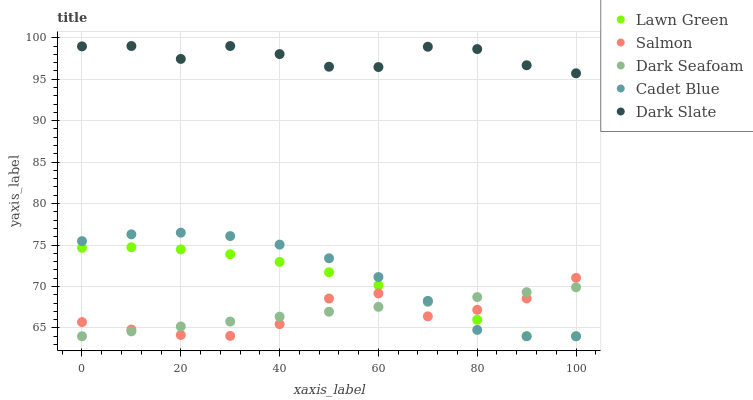Does Salmon have the minimum area under the curve?
Answer yes or no. Yes. Does Dark Slate have the maximum area under the curve?
Answer yes or no. Yes. Does Dark Seafoam have the minimum area under the curve?
Answer yes or no. No. Does Dark Seafoam have the maximum area under the curve?
Answer yes or no. No. Is Dark Seafoam the smoothest?
Answer yes or no. Yes. Is Dark Slate the roughest?
Answer yes or no. Yes. Is Cadet Blue the smoothest?
Answer yes or no. No. Is Cadet Blue the roughest?
Answer yes or no. No. Does Lawn Green have the lowest value?
Answer yes or no. Yes. Does Salmon have the lowest value?
Answer yes or no. No. Does Dark Slate have the highest value?
Answer yes or no. Yes. Does Cadet Blue have the highest value?
Answer yes or no. No. Is Salmon less than Dark Slate?
Answer yes or no. Yes. Is Dark Slate greater than Cadet Blue?
Answer yes or no. Yes. Does Cadet Blue intersect Lawn Green?
Answer yes or no. Yes. Is Cadet Blue less than Lawn Green?
Answer yes or no. No. Is Cadet Blue greater than Lawn Green?
Answer yes or no. No. Does Salmon intersect Dark Slate?
Answer yes or no. No. 